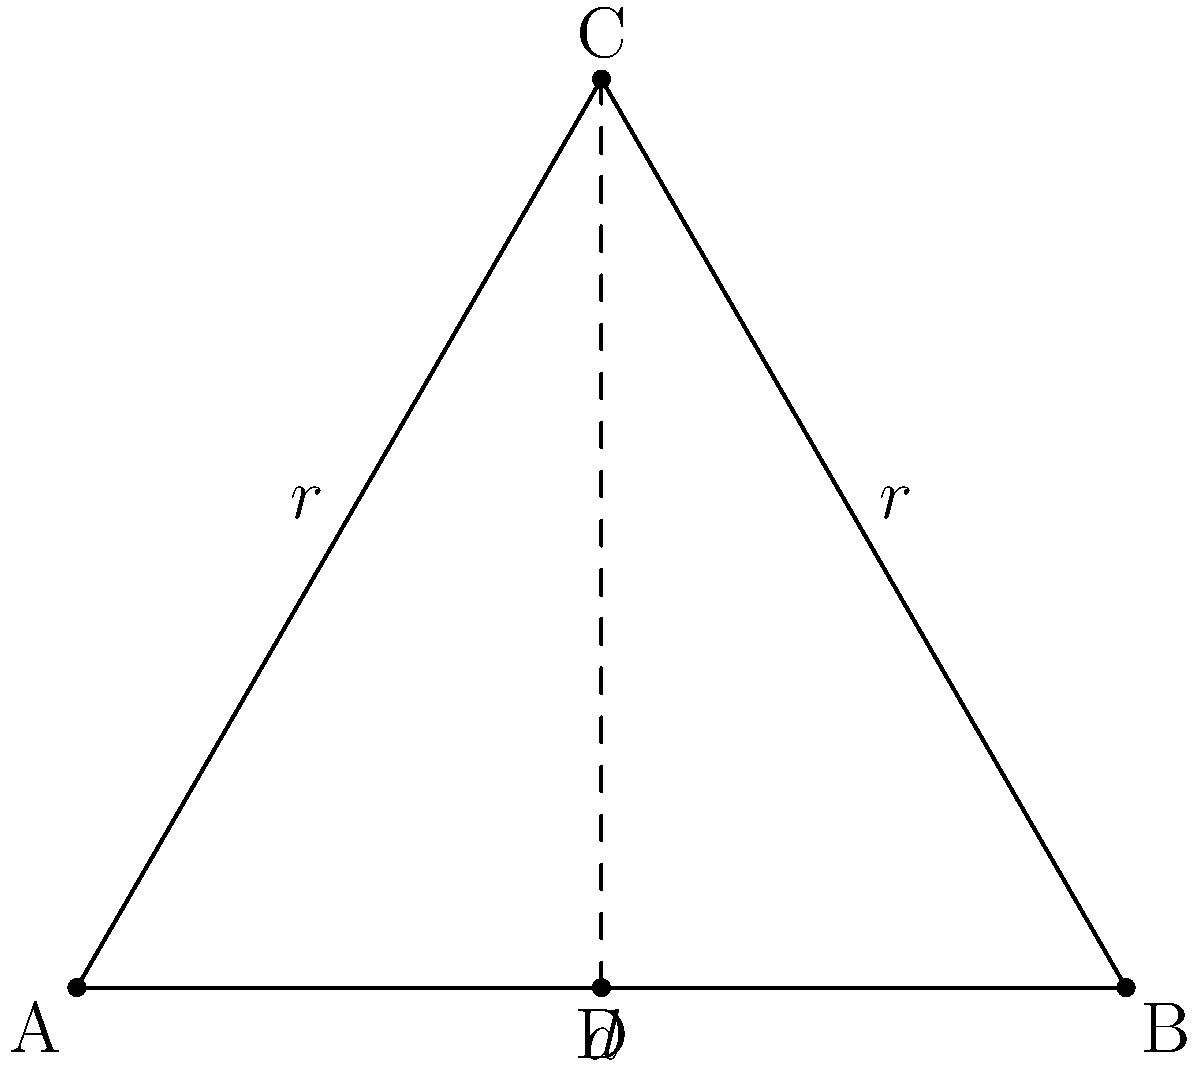In a triangular swarm formation of drones, the base length $d$ represents the spacing between two drones, and $r$ is the maximum effective range of each drone. If the goal is to maximize the coverage area while maintaining connectivity, what should be the optimal ratio of $d$ to $r$? Let's approach this step-by-step:

1) The triangle formed by the three drones is equilateral, as all drones should have equal spacing for optimal coverage.

2) In an equilateral triangle, the height ($h$) is related to the side length ($d$) by the formula:
   $h = \frac{\sqrt{3}}{2}d$

3) The radius $r$ of the drone's coverage is equal to this height:
   $r = \frac{\sqrt{3}}{2}d$

4) To find the ratio $\frac{d}{r}$, we divide both sides by $r$:
   $1 = \frac{\sqrt{3}}{2} \cdot \frac{d}{r}$

5) Solving for $\frac{d}{r}$:
   $\frac{d}{r} = \frac{2}{\sqrt{3}} \approx 1.155$

6) This ratio ensures that the coverage areas of the drones just touch each other, maximizing coverage while maintaining connectivity.
Answer: $\frac{d}{r} = \frac{2}{\sqrt{3}}$ 